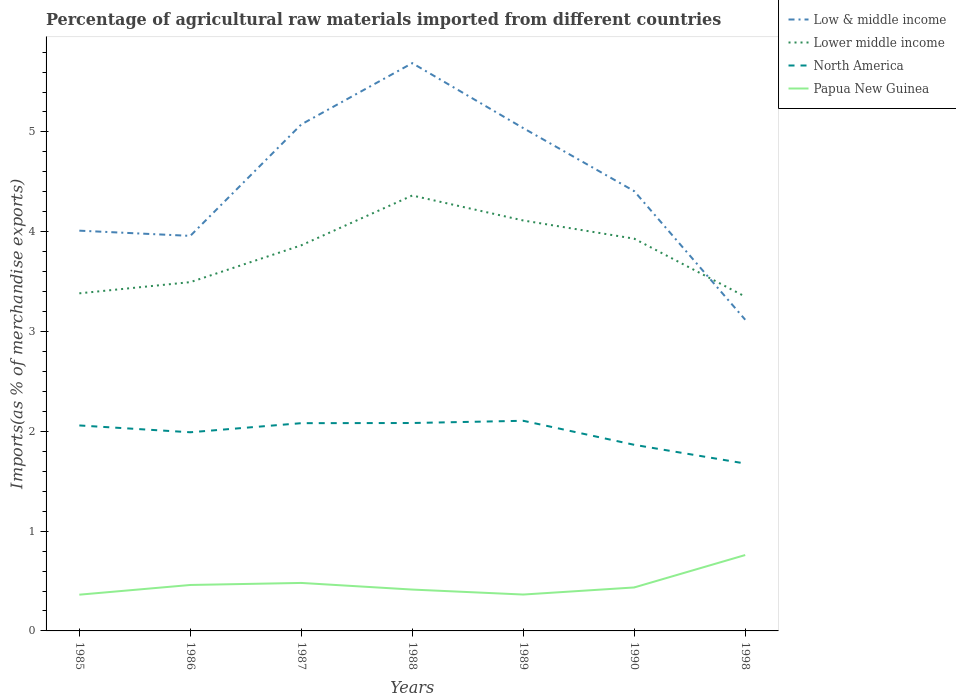Does the line corresponding to Low & middle income intersect with the line corresponding to North America?
Provide a succinct answer. No. Across all years, what is the maximum percentage of imports to different countries in Low & middle income?
Ensure brevity in your answer.  3.12. In which year was the percentage of imports to different countries in Lower middle income maximum?
Make the answer very short. 1998. What is the total percentage of imports to different countries in Low & middle income in the graph?
Keep it short and to the point. 1.28. What is the difference between the highest and the second highest percentage of imports to different countries in North America?
Make the answer very short. 0.43. What is the difference between the highest and the lowest percentage of imports to different countries in Low & middle income?
Your response must be concise. 3. Is the percentage of imports to different countries in Lower middle income strictly greater than the percentage of imports to different countries in Papua New Guinea over the years?
Keep it short and to the point. No. How many years are there in the graph?
Your answer should be compact. 7. Are the values on the major ticks of Y-axis written in scientific E-notation?
Offer a very short reply. No. Where does the legend appear in the graph?
Ensure brevity in your answer.  Top right. How many legend labels are there?
Your response must be concise. 4. What is the title of the graph?
Give a very brief answer. Percentage of agricultural raw materials imported from different countries. Does "Uzbekistan" appear as one of the legend labels in the graph?
Provide a short and direct response. No. What is the label or title of the X-axis?
Offer a very short reply. Years. What is the label or title of the Y-axis?
Provide a succinct answer. Imports(as % of merchandise exports). What is the Imports(as % of merchandise exports) in Low & middle income in 1985?
Offer a very short reply. 4.01. What is the Imports(as % of merchandise exports) of Lower middle income in 1985?
Keep it short and to the point. 3.38. What is the Imports(as % of merchandise exports) in North America in 1985?
Keep it short and to the point. 2.06. What is the Imports(as % of merchandise exports) in Papua New Guinea in 1985?
Your answer should be compact. 0.36. What is the Imports(as % of merchandise exports) in Low & middle income in 1986?
Give a very brief answer. 3.96. What is the Imports(as % of merchandise exports) of Lower middle income in 1986?
Provide a succinct answer. 3.5. What is the Imports(as % of merchandise exports) of North America in 1986?
Your answer should be compact. 1.99. What is the Imports(as % of merchandise exports) of Papua New Guinea in 1986?
Make the answer very short. 0.46. What is the Imports(as % of merchandise exports) in Low & middle income in 1987?
Make the answer very short. 5.08. What is the Imports(as % of merchandise exports) in Lower middle income in 1987?
Provide a short and direct response. 3.86. What is the Imports(as % of merchandise exports) of North America in 1987?
Make the answer very short. 2.08. What is the Imports(as % of merchandise exports) of Papua New Guinea in 1987?
Offer a very short reply. 0.48. What is the Imports(as % of merchandise exports) of Low & middle income in 1988?
Offer a very short reply. 5.69. What is the Imports(as % of merchandise exports) in Lower middle income in 1988?
Make the answer very short. 4.36. What is the Imports(as % of merchandise exports) in North America in 1988?
Offer a very short reply. 2.08. What is the Imports(as % of merchandise exports) in Papua New Guinea in 1988?
Provide a succinct answer. 0.41. What is the Imports(as % of merchandise exports) in Low & middle income in 1989?
Provide a short and direct response. 5.04. What is the Imports(as % of merchandise exports) in Lower middle income in 1989?
Keep it short and to the point. 4.11. What is the Imports(as % of merchandise exports) of North America in 1989?
Your answer should be very brief. 2.11. What is the Imports(as % of merchandise exports) in Papua New Guinea in 1989?
Provide a succinct answer. 0.36. What is the Imports(as % of merchandise exports) in Low & middle income in 1990?
Offer a very short reply. 4.41. What is the Imports(as % of merchandise exports) in Lower middle income in 1990?
Your answer should be very brief. 3.93. What is the Imports(as % of merchandise exports) of North America in 1990?
Keep it short and to the point. 1.86. What is the Imports(as % of merchandise exports) of Papua New Guinea in 1990?
Give a very brief answer. 0.44. What is the Imports(as % of merchandise exports) of Low & middle income in 1998?
Your answer should be very brief. 3.12. What is the Imports(as % of merchandise exports) in Lower middle income in 1998?
Make the answer very short. 3.35. What is the Imports(as % of merchandise exports) in North America in 1998?
Keep it short and to the point. 1.68. What is the Imports(as % of merchandise exports) of Papua New Guinea in 1998?
Provide a short and direct response. 0.76. Across all years, what is the maximum Imports(as % of merchandise exports) in Low & middle income?
Give a very brief answer. 5.69. Across all years, what is the maximum Imports(as % of merchandise exports) of Lower middle income?
Offer a very short reply. 4.36. Across all years, what is the maximum Imports(as % of merchandise exports) in North America?
Offer a very short reply. 2.11. Across all years, what is the maximum Imports(as % of merchandise exports) of Papua New Guinea?
Your response must be concise. 0.76. Across all years, what is the minimum Imports(as % of merchandise exports) of Low & middle income?
Ensure brevity in your answer.  3.12. Across all years, what is the minimum Imports(as % of merchandise exports) in Lower middle income?
Provide a succinct answer. 3.35. Across all years, what is the minimum Imports(as % of merchandise exports) in North America?
Make the answer very short. 1.68. Across all years, what is the minimum Imports(as % of merchandise exports) in Papua New Guinea?
Offer a very short reply. 0.36. What is the total Imports(as % of merchandise exports) of Low & middle income in the graph?
Ensure brevity in your answer.  31.3. What is the total Imports(as % of merchandise exports) of Lower middle income in the graph?
Make the answer very short. 26.5. What is the total Imports(as % of merchandise exports) in North America in the graph?
Your response must be concise. 13.86. What is the total Imports(as % of merchandise exports) of Papua New Guinea in the graph?
Your answer should be very brief. 3.28. What is the difference between the Imports(as % of merchandise exports) of Low & middle income in 1985 and that in 1986?
Your answer should be very brief. 0.05. What is the difference between the Imports(as % of merchandise exports) of Lower middle income in 1985 and that in 1986?
Give a very brief answer. -0.11. What is the difference between the Imports(as % of merchandise exports) of North America in 1985 and that in 1986?
Keep it short and to the point. 0.07. What is the difference between the Imports(as % of merchandise exports) in Papua New Guinea in 1985 and that in 1986?
Offer a very short reply. -0.1. What is the difference between the Imports(as % of merchandise exports) in Low & middle income in 1985 and that in 1987?
Offer a terse response. -1.06. What is the difference between the Imports(as % of merchandise exports) in Lower middle income in 1985 and that in 1987?
Keep it short and to the point. -0.48. What is the difference between the Imports(as % of merchandise exports) in North America in 1985 and that in 1987?
Your answer should be very brief. -0.02. What is the difference between the Imports(as % of merchandise exports) of Papua New Guinea in 1985 and that in 1987?
Provide a short and direct response. -0.12. What is the difference between the Imports(as % of merchandise exports) in Low & middle income in 1985 and that in 1988?
Provide a short and direct response. -1.68. What is the difference between the Imports(as % of merchandise exports) of Lower middle income in 1985 and that in 1988?
Provide a short and direct response. -0.98. What is the difference between the Imports(as % of merchandise exports) in North America in 1985 and that in 1988?
Provide a short and direct response. -0.02. What is the difference between the Imports(as % of merchandise exports) in Papua New Guinea in 1985 and that in 1988?
Your answer should be compact. -0.05. What is the difference between the Imports(as % of merchandise exports) of Low & middle income in 1985 and that in 1989?
Give a very brief answer. -1.03. What is the difference between the Imports(as % of merchandise exports) of Lower middle income in 1985 and that in 1989?
Offer a terse response. -0.73. What is the difference between the Imports(as % of merchandise exports) of North America in 1985 and that in 1989?
Your answer should be very brief. -0.05. What is the difference between the Imports(as % of merchandise exports) of Papua New Guinea in 1985 and that in 1989?
Your answer should be compact. -0. What is the difference between the Imports(as % of merchandise exports) of Low & middle income in 1985 and that in 1990?
Your response must be concise. -0.4. What is the difference between the Imports(as % of merchandise exports) of Lower middle income in 1985 and that in 1990?
Give a very brief answer. -0.55. What is the difference between the Imports(as % of merchandise exports) of North America in 1985 and that in 1990?
Offer a very short reply. 0.19. What is the difference between the Imports(as % of merchandise exports) of Papua New Guinea in 1985 and that in 1990?
Your answer should be compact. -0.07. What is the difference between the Imports(as % of merchandise exports) of Low & middle income in 1985 and that in 1998?
Ensure brevity in your answer.  0.89. What is the difference between the Imports(as % of merchandise exports) of Lower middle income in 1985 and that in 1998?
Make the answer very short. 0.03. What is the difference between the Imports(as % of merchandise exports) in North America in 1985 and that in 1998?
Ensure brevity in your answer.  0.38. What is the difference between the Imports(as % of merchandise exports) of Papua New Guinea in 1985 and that in 1998?
Make the answer very short. -0.4. What is the difference between the Imports(as % of merchandise exports) in Low & middle income in 1986 and that in 1987?
Offer a terse response. -1.12. What is the difference between the Imports(as % of merchandise exports) of Lower middle income in 1986 and that in 1987?
Make the answer very short. -0.37. What is the difference between the Imports(as % of merchandise exports) of North America in 1986 and that in 1987?
Give a very brief answer. -0.09. What is the difference between the Imports(as % of merchandise exports) in Papua New Guinea in 1986 and that in 1987?
Offer a terse response. -0.02. What is the difference between the Imports(as % of merchandise exports) of Low & middle income in 1986 and that in 1988?
Make the answer very short. -1.73. What is the difference between the Imports(as % of merchandise exports) of Lower middle income in 1986 and that in 1988?
Your response must be concise. -0.87. What is the difference between the Imports(as % of merchandise exports) in North America in 1986 and that in 1988?
Give a very brief answer. -0.09. What is the difference between the Imports(as % of merchandise exports) of Papua New Guinea in 1986 and that in 1988?
Provide a short and direct response. 0.05. What is the difference between the Imports(as % of merchandise exports) in Low & middle income in 1986 and that in 1989?
Provide a succinct answer. -1.08. What is the difference between the Imports(as % of merchandise exports) of Lower middle income in 1986 and that in 1989?
Ensure brevity in your answer.  -0.62. What is the difference between the Imports(as % of merchandise exports) of North America in 1986 and that in 1989?
Make the answer very short. -0.12. What is the difference between the Imports(as % of merchandise exports) in Papua New Guinea in 1986 and that in 1989?
Keep it short and to the point. 0.1. What is the difference between the Imports(as % of merchandise exports) in Low & middle income in 1986 and that in 1990?
Your response must be concise. -0.45. What is the difference between the Imports(as % of merchandise exports) of Lower middle income in 1986 and that in 1990?
Make the answer very short. -0.44. What is the difference between the Imports(as % of merchandise exports) in North America in 1986 and that in 1990?
Make the answer very short. 0.13. What is the difference between the Imports(as % of merchandise exports) in Papua New Guinea in 1986 and that in 1990?
Give a very brief answer. 0.02. What is the difference between the Imports(as % of merchandise exports) in Low & middle income in 1986 and that in 1998?
Give a very brief answer. 0.84. What is the difference between the Imports(as % of merchandise exports) in Lower middle income in 1986 and that in 1998?
Provide a short and direct response. 0.15. What is the difference between the Imports(as % of merchandise exports) in North America in 1986 and that in 1998?
Your answer should be compact. 0.31. What is the difference between the Imports(as % of merchandise exports) in Papua New Guinea in 1986 and that in 1998?
Give a very brief answer. -0.3. What is the difference between the Imports(as % of merchandise exports) of Low & middle income in 1987 and that in 1988?
Your answer should be very brief. -0.61. What is the difference between the Imports(as % of merchandise exports) of Lower middle income in 1987 and that in 1988?
Your answer should be compact. -0.5. What is the difference between the Imports(as % of merchandise exports) of North America in 1987 and that in 1988?
Offer a terse response. -0. What is the difference between the Imports(as % of merchandise exports) in Papua New Guinea in 1987 and that in 1988?
Ensure brevity in your answer.  0.07. What is the difference between the Imports(as % of merchandise exports) of Low & middle income in 1987 and that in 1989?
Your response must be concise. 0.04. What is the difference between the Imports(as % of merchandise exports) in Lower middle income in 1987 and that in 1989?
Your response must be concise. -0.25. What is the difference between the Imports(as % of merchandise exports) in North America in 1987 and that in 1989?
Your answer should be compact. -0.02. What is the difference between the Imports(as % of merchandise exports) of Papua New Guinea in 1987 and that in 1989?
Your response must be concise. 0.12. What is the difference between the Imports(as % of merchandise exports) in Low & middle income in 1987 and that in 1990?
Ensure brevity in your answer.  0.67. What is the difference between the Imports(as % of merchandise exports) in Lower middle income in 1987 and that in 1990?
Ensure brevity in your answer.  -0.07. What is the difference between the Imports(as % of merchandise exports) in North America in 1987 and that in 1990?
Make the answer very short. 0.22. What is the difference between the Imports(as % of merchandise exports) in Papua New Guinea in 1987 and that in 1990?
Provide a short and direct response. 0.05. What is the difference between the Imports(as % of merchandise exports) in Low & middle income in 1987 and that in 1998?
Offer a very short reply. 1.96. What is the difference between the Imports(as % of merchandise exports) in Lower middle income in 1987 and that in 1998?
Offer a terse response. 0.51. What is the difference between the Imports(as % of merchandise exports) in North America in 1987 and that in 1998?
Offer a terse response. 0.4. What is the difference between the Imports(as % of merchandise exports) in Papua New Guinea in 1987 and that in 1998?
Your answer should be compact. -0.28. What is the difference between the Imports(as % of merchandise exports) of Low & middle income in 1988 and that in 1989?
Your response must be concise. 0.65. What is the difference between the Imports(as % of merchandise exports) of Lower middle income in 1988 and that in 1989?
Offer a very short reply. 0.25. What is the difference between the Imports(as % of merchandise exports) of North America in 1988 and that in 1989?
Offer a terse response. -0.02. What is the difference between the Imports(as % of merchandise exports) of Papua New Guinea in 1988 and that in 1989?
Provide a short and direct response. 0.05. What is the difference between the Imports(as % of merchandise exports) in Low & middle income in 1988 and that in 1990?
Your response must be concise. 1.28. What is the difference between the Imports(as % of merchandise exports) of Lower middle income in 1988 and that in 1990?
Ensure brevity in your answer.  0.43. What is the difference between the Imports(as % of merchandise exports) of North America in 1988 and that in 1990?
Provide a short and direct response. 0.22. What is the difference between the Imports(as % of merchandise exports) in Papua New Guinea in 1988 and that in 1990?
Your answer should be very brief. -0.02. What is the difference between the Imports(as % of merchandise exports) in Low & middle income in 1988 and that in 1998?
Your answer should be very brief. 2.57. What is the difference between the Imports(as % of merchandise exports) of Lower middle income in 1988 and that in 1998?
Make the answer very short. 1.01. What is the difference between the Imports(as % of merchandise exports) of North America in 1988 and that in 1998?
Provide a short and direct response. 0.41. What is the difference between the Imports(as % of merchandise exports) of Papua New Guinea in 1988 and that in 1998?
Provide a short and direct response. -0.35. What is the difference between the Imports(as % of merchandise exports) in Low & middle income in 1989 and that in 1990?
Make the answer very short. 0.63. What is the difference between the Imports(as % of merchandise exports) in Lower middle income in 1989 and that in 1990?
Offer a terse response. 0.18. What is the difference between the Imports(as % of merchandise exports) in North America in 1989 and that in 1990?
Ensure brevity in your answer.  0.24. What is the difference between the Imports(as % of merchandise exports) in Papua New Guinea in 1989 and that in 1990?
Your answer should be very brief. -0.07. What is the difference between the Imports(as % of merchandise exports) in Low & middle income in 1989 and that in 1998?
Keep it short and to the point. 1.92. What is the difference between the Imports(as % of merchandise exports) in Lower middle income in 1989 and that in 1998?
Keep it short and to the point. 0.76. What is the difference between the Imports(as % of merchandise exports) of North America in 1989 and that in 1998?
Give a very brief answer. 0.43. What is the difference between the Imports(as % of merchandise exports) of Papua New Guinea in 1989 and that in 1998?
Provide a short and direct response. -0.4. What is the difference between the Imports(as % of merchandise exports) of Low & middle income in 1990 and that in 1998?
Keep it short and to the point. 1.29. What is the difference between the Imports(as % of merchandise exports) in Lower middle income in 1990 and that in 1998?
Your response must be concise. 0.58. What is the difference between the Imports(as % of merchandise exports) in North America in 1990 and that in 1998?
Your answer should be compact. 0.19. What is the difference between the Imports(as % of merchandise exports) of Papua New Guinea in 1990 and that in 1998?
Provide a short and direct response. -0.32. What is the difference between the Imports(as % of merchandise exports) in Low & middle income in 1985 and the Imports(as % of merchandise exports) in Lower middle income in 1986?
Make the answer very short. 0.52. What is the difference between the Imports(as % of merchandise exports) in Low & middle income in 1985 and the Imports(as % of merchandise exports) in North America in 1986?
Provide a succinct answer. 2.02. What is the difference between the Imports(as % of merchandise exports) of Low & middle income in 1985 and the Imports(as % of merchandise exports) of Papua New Guinea in 1986?
Offer a terse response. 3.55. What is the difference between the Imports(as % of merchandise exports) of Lower middle income in 1985 and the Imports(as % of merchandise exports) of North America in 1986?
Keep it short and to the point. 1.39. What is the difference between the Imports(as % of merchandise exports) of Lower middle income in 1985 and the Imports(as % of merchandise exports) of Papua New Guinea in 1986?
Offer a very short reply. 2.92. What is the difference between the Imports(as % of merchandise exports) of North America in 1985 and the Imports(as % of merchandise exports) of Papua New Guinea in 1986?
Your answer should be compact. 1.6. What is the difference between the Imports(as % of merchandise exports) of Low & middle income in 1985 and the Imports(as % of merchandise exports) of Lower middle income in 1987?
Give a very brief answer. 0.15. What is the difference between the Imports(as % of merchandise exports) of Low & middle income in 1985 and the Imports(as % of merchandise exports) of North America in 1987?
Provide a succinct answer. 1.93. What is the difference between the Imports(as % of merchandise exports) of Low & middle income in 1985 and the Imports(as % of merchandise exports) of Papua New Guinea in 1987?
Your response must be concise. 3.53. What is the difference between the Imports(as % of merchandise exports) in Lower middle income in 1985 and the Imports(as % of merchandise exports) in North America in 1987?
Your response must be concise. 1.3. What is the difference between the Imports(as % of merchandise exports) in Lower middle income in 1985 and the Imports(as % of merchandise exports) in Papua New Guinea in 1987?
Offer a terse response. 2.9. What is the difference between the Imports(as % of merchandise exports) of North America in 1985 and the Imports(as % of merchandise exports) of Papua New Guinea in 1987?
Give a very brief answer. 1.58. What is the difference between the Imports(as % of merchandise exports) of Low & middle income in 1985 and the Imports(as % of merchandise exports) of Lower middle income in 1988?
Give a very brief answer. -0.35. What is the difference between the Imports(as % of merchandise exports) in Low & middle income in 1985 and the Imports(as % of merchandise exports) in North America in 1988?
Your response must be concise. 1.93. What is the difference between the Imports(as % of merchandise exports) of Low & middle income in 1985 and the Imports(as % of merchandise exports) of Papua New Guinea in 1988?
Offer a terse response. 3.6. What is the difference between the Imports(as % of merchandise exports) in Lower middle income in 1985 and the Imports(as % of merchandise exports) in North America in 1988?
Offer a very short reply. 1.3. What is the difference between the Imports(as % of merchandise exports) of Lower middle income in 1985 and the Imports(as % of merchandise exports) of Papua New Guinea in 1988?
Your answer should be very brief. 2.97. What is the difference between the Imports(as % of merchandise exports) in North America in 1985 and the Imports(as % of merchandise exports) in Papua New Guinea in 1988?
Offer a very short reply. 1.64. What is the difference between the Imports(as % of merchandise exports) in Low & middle income in 1985 and the Imports(as % of merchandise exports) in Lower middle income in 1989?
Your answer should be very brief. -0.1. What is the difference between the Imports(as % of merchandise exports) in Low & middle income in 1985 and the Imports(as % of merchandise exports) in North America in 1989?
Provide a short and direct response. 1.91. What is the difference between the Imports(as % of merchandise exports) of Low & middle income in 1985 and the Imports(as % of merchandise exports) of Papua New Guinea in 1989?
Provide a short and direct response. 3.65. What is the difference between the Imports(as % of merchandise exports) in Lower middle income in 1985 and the Imports(as % of merchandise exports) in North America in 1989?
Ensure brevity in your answer.  1.28. What is the difference between the Imports(as % of merchandise exports) in Lower middle income in 1985 and the Imports(as % of merchandise exports) in Papua New Guinea in 1989?
Provide a short and direct response. 3.02. What is the difference between the Imports(as % of merchandise exports) in North America in 1985 and the Imports(as % of merchandise exports) in Papua New Guinea in 1989?
Make the answer very short. 1.69. What is the difference between the Imports(as % of merchandise exports) in Low & middle income in 1985 and the Imports(as % of merchandise exports) in Lower middle income in 1990?
Provide a short and direct response. 0.08. What is the difference between the Imports(as % of merchandise exports) in Low & middle income in 1985 and the Imports(as % of merchandise exports) in North America in 1990?
Ensure brevity in your answer.  2.15. What is the difference between the Imports(as % of merchandise exports) in Low & middle income in 1985 and the Imports(as % of merchandise exports) in Papua New Guinea in 1990?
Your response must be concise. 3.58. What is the difference between the Imports(as % of merchandise exports) in Lower middle income in 1985 and the Imports(as % of merchandise exports) in North America in 1990?
Offer a terse response. 1.52. What is the difference between the Imports(as % of merchandise exports) of Lower middle income in 1985 and the Imports(as % of merchandise exports) of Papua New Guinea in 1990?
Make the answer very short. 2.95. What is the difference between the Imports(as % of merchandise exports) in North America in 1985 and the Imports(as % of merchandise exports) in Papua New Guinea in 1990?
Your answer should be compact. 1.62. What is the difference between the Imports(as % of merchandise exports) in Low & middle income in 1985 and the Imports(as % of merchandise exports) in Lower middle income in 1998?
Give a very brief answer. 0.66. What is the difference between the Imports(as % of merchandise exports) in Low & middle income in 1985 and the Imports(as % of merchandise exports) in North America in 1998?
Your answer should be compact. 2.33. What is the difference between the Imports(as % of merchandise exports) in Low & middle income in 1985 and the Imports(as % of merchandise exports) in Papua New Guinea in 1998?
Provide a succinct answer. 3.25. What is the difference between the Imports(as % of merchandise exports) of Lower middle income in 1985 and the Imports(as % of merchandise exports) of North America in 1998?
Your answer should be very brief. 1.71. What is the difference between the Imports(as % of merchandise exports) of Lower middle income in 1985 and the Imports(as % of merchandise exports) of Papua New Guinea in 1998?
Offer a very short reply. 2.62. What is the difference between the Imports(as % of merchandise exports) of North America in 1985 and the Imports(as % of merchandise exports) of Papua New Guinea in 1998?
Provide a succinct answer. 1.3. What is the difference between the Imports(as % of merchandise exports) in Low & middle income in 1986 and the Imports(as % of merchandise exports) in Lower middle income in 1987?
Ensure brevity in your answer.  0.09. What is the difference between the Imports(as % of merchandise exports) in Low & middle income in 1986 and the Imports(as % of merchandise exports) in North America in 1987?
Make the answer very short. 1.88. What is the difference between the Imports(as % of merchandise exports) of Low & middle income in 1986 and the Imports(as % of merchandise exports) of Papua New Guinea in 1987?
Ensure brevity in your answer.  3.48. What is the difference between the Imports(as % of merchandise exports) of Lower middle income in 1986 and the Imports(as % of merchandise exports) of North America in 1987?
Keep it short and to the point. 1.41. What is the difference between the Imports(as % of merchandise exports) of Lower middle income in 1986 and the Imports(as % of merchandise exports) of Papua New Guinea in 1987?
Provide a succinct answer. 3.01. What is the difference between the Imports(as % of merchandise exports) of North America in 1986 and the Imports(as % of merchandise exports) of Papua New Guinea in 1987?
Keep it short and to the point. 1.51. What is the difference between the Imports(as % of merchandise exports) in Low & middle income in 1986 and the Imports(as % of merchandise exports) in Lower middle income in 1988?
Offer a very short reply. -0.4. What is the difference between the Imports(as % of merchandise exports) of Low & middle income in 1986 and the Imports(as % of merchandise exports) of North America in 1988?
Give a very brief answer. 1.88. What is the difference between the Imports(as % of merchandise exports) of Low & middle income in 1986 and the Imports(as % of merchandise exports) of Papua New Guinea in 1988?
Your answer should be compact. 3.54. What is the difference between the Imports(as % of merchandise exports) of Lower middle income in 1986 and the Imports(as % of merchandise exports) of North America in 1988?
Offer a terse response. 1.41. What is the difference between the Imports(as % of merchandise exports) of Lower middle income in 1986 and the Imports(as % of merchandise exports) of Papua New Guinea in 1988?
Offer a terse response. 3.08. What is the difference between the Imports(as % of merchandise exports) of North America in 1986 and the Imports(as % of merchandise exports) of Papua New Guinea in 1988?
Keep it short and to the point. 1.58. What is the difference between the Imports(as % of merchandise exports) of Low & middle income in 1986 and the Imports(as % of merchandise exports) of Lower middle income in 1989?
Offer a very short reply. -0.15. What is the difference between the Imports(as % of merchandise exports) in Low & middle income in 1986 and the Imports(as % of merchandise exports) in North America in 1989?
Ensure brevity in your answer.  1.85. What is the difference between the Imports(as % of merchandise exports) in Low & middle income in 1986 and the Imports(as % of merchandise exports) in Papua New Guinea in 1989?
Provide a short and direct response. 3.59. What is the difference between the Imports(as % of merchandise exports) in Lower middle income in 1986 and the Imports(as % of merchandise exports) in North America in 1989?
Your answer should be compact. 1.39. What is the difference between the Imports(as % of merchandise exports) of Lower middle income in 1986 and the Imports(as % of merchandise exports) of Papua New Guinea in 1989?
Your answer should be very brief. 3.13. What is the difference between the Imports(as % of merchandise exports) in North America in 1986 and the Imports(as % of merchandise exports) in Papua New Guinea in 1989?
Ensure brevity in your answer.  1.63. What is the difference between the Imports(as % of merchandise exports) in Low & middle income in 1986 and the Imports(as % of merchandise exports) in Lower middle income in 1990?
Your answer should be very brief. 0.03. What is the difference between the Imports(as % of merchandise exports) in Low & middle income in 1986 and the Imports(as % of merchandise exports) in North America in 1990?
Keep it short and to the point. 2.09. What is the difference between the Imports(as % of merchandise exports) of Low & middle income in 1986 and the Imports(as % of merchandise exports) of Papua New Guinea in 1990?
Offer a terse response. 3.52. What is the difference between the Imports(as % of merchandise exports) in Lower middle income in 1986 and the Imports(as % of merchandise exports) in North America in 1990?
Provide a succinct answer. 1.63. What is the difference between the Imports(as % of merchandise exports) of Lower middle income in 1986 and the Imports(as % of merchandise exports) of Papua New Guinea in 1990?
Ensure brevity in your answer.  3.06. What is the difference between the Imports(as % of merchandise exports) of North America in 1986 and the Imports(as % of merchandise exports) of Papua New Guinea in 1990?
Ensure brevity in your answer.  1.55. What is the difference between the Imports(as % of merchandise exports) of Low & middle income in 1986 and the Imports(as % of merchandise exports) of Lower middle income in 1998?
Ensure brevity in your answer.  0.61. What is the difference between the Imports(as % of merchandise exports) of Low & middle income in 1986 and the Imports(as % of merchandise exports) of North America in 1998?
Offer a very short reply. 2.28. What is the difference between the Imports(as % of merchandise exports) in Low & middle income in 1986 and the Imports(as % of merchandise exports) in Papua New Guinea in 1998?
Offer a terse response. 3.2. What is the difference between the Imports(as % of merchandise exports) in Lower middle income in 1986 and the Imports(as % of merchandise exports) in North America in 1998?
Make the answer very short. 1.82. What is the difference between the Imports(as % of merchandise exports) of Lower middle income in 1986 and the Imports(as % of merchandise exports) of Papua New Guinea in 1998?
Provide a succinct answer. 2.73. What is the difference between the Imports(as % of merchandise exports) of North America in 1986 and the Imports(as % of merchandise exports) of Papua New Guinea in 1998?
Your response must be concise. 1.23. What is the difference between the Imports(as % of merchandise exports) of Low & middle income in 1987 and the Imports(as % of merchandise exports) of Lower middle income in 1988?
Provide a succinct answer. 0.71. What is the difference between the Imports(as % of merchandise exports) of Low & middle income in 1987 and the Imports(as % of merchandise exports) of North America in 1988?
Keep it short and to the point. 2.99. What is the difference between the Imports(as % of merchandise exports) in Low & middle income in 1987 and the Imports(as % of merchandise exports) in Papua New Guinea in 1988?
Offer a very short reply. 4.66. What is the difference between the Imports(as % of merchandise exports) of Lower middle income in 1987 and the Imports(as % of merchandise exports) of North America in 1988?
Provide a short and direct response. 1.78. What is the difference between the Imports(as % of merchandise exports) of Lower middle income in 1987 and the Imports(as % of merchandise exports) of Papua New Guinea in 1988?
Provide a short and direct response. 3.45. What is the difference between the Imports(as % of merchandise exports) of North America in 1987 and the Imports(as % of merchandise exports) of Papua New Guinea in 1988?
Ensure brevity in your answer.  1.67. What is the difference between the Imports(as % of merchandise exports) of Low & middle income in 1987 and the Imports(as % of merchandise exports) of Lower middle income in 1989?
Your answer should be very brief. 0.96. What is the difference between the Imports(as % of merchandise exports) in Low & middle income in 1987 and the Imports(as % of merchandise exports) in North America in 1989?
Offer a very short reply. 2.97. What is the difference between the Imports(as % of merchandise exports) in Low & middle income in 1987 and the Imports(as % of merchandise exports) in Papua New Guinea in 1989?
Make the answer very short. 4.71. What is the difference between the Imports(as % of merchandise exports) of Lower middle income in 1987 and the Imports(as % of merchandise exports) of North America in 1989?
Your answer should be compact. 1.76. What is the difference between the Imports(as % of merchandise exports) of Lower middle income in 1987 and the Imports(as % of merchandise exports) of Papua New Guinea in 1989?
Provide a short and direct response. 3.5. What is the difference between the Imports(as % of merchandise exports) in North America in 1987 and the Imports(as % of merchandise exports) in Papua New Guinea in 1989?
Your answer should be very brief. 1.72. What is the difference between the Imports(as % of merchandise exports) in Low & middle income in 1987 and the Imports(as % of merchandise exports) in Lower middle income in 1990?
Your response must be concise. 1.15. What is the difference between the Imports(as % of merchandise exports) of Low & middle income in 1987 and the Imports(as % of merchandise exports) of North America in 1990?
Offer a very short reply. 3.21. What is the difference between the Imports(as % of merchandise exports) of Low & middle income in 1987 and the Imports(as % of merchandise exports) of Papua New Guinea in 1990?
Your answer should be compact. 4.64. What is the difference between the Imports(as % of merchandise exports) in Lower middle income in 1987 and the Imports(as % of merchandise exports) in North America in 1990?
Your response must be concise. 2. What is the difference between the Imports(as % of merchandise exports) of Lower middle income in 1987 and the Imports(as % of merchandise exports) of Papua New Guinea in 1990?
Give a very brief answer. 3.43. What is the difference between the Imports(as % of merchandise exports) of North America in 1987 and the Imports(as % of merchandise exports) of Papua New Guinea in 1990?
Give a very brief answer. 1.65. What is the difference between the Imports(as % of merchandise exports) in Low & middle income in 1987 and the Imports(as % of merchandise exports) in Lower middle income in 1998?
Your answer should be compact. 1.73. What is the difference between the Imports(as % of merchandise exports) in Low & middle income in 1987 and the Imports(as % of merchandise exports) in North America in 1998?
Offer a very short reply. 3.4. What is the difference between the Imports(as % of merchandise exports) in Low & middle income in 1987 and the Imports(as % of merchandise exports) in Papua New Guinea in 1998?
Offer a terse response. 4.31. What is the difference between the Imports(as % of merchandise exports) in Lower middle income in 1987 and the Imports(as % of merchandise exports) in North America in 1998?
Give a very brief answer. 2.19. What is the difference between the Imports(as % of merchandise exports) of Lower middle income in 1987 and the Imports(as % of merchandise exports) of Papua New Guinea in 1998?
Keep it short and to the point. 3.1. What is the difference between the Imports(as % of merchandise exports) in North America in 1987 and the Imports(as % of merchandise exports) in Papua New Guinea in 1998?
Ensure brevity in your answer.  1.32. What is the difference between the Imports(as % of merchandise exports) in Low & middle income in 1988 and the Imports(as % of merchandise exports) in Lower middle income in 1989?
Keep it short and to the point. 1.58. What is the difference between the Imports(as % of merchandise exports) in Low & middle income in 1988 and the Imports(as % of merchandise exports) in North America in 1989?
Provide a short and direct response. 3.58. What is the difference between the Imports(as % of merchandise exports) of Low & middle income in 1988 and the Imports(as % of merchandise exports) of Papua New Guinea in 1989?
Your response must be concise. 5.32. What is the difference between the Imports(as % of merchandise exports) in Lower middle income in 1988 and the Imports(as % of merchandise exports) in North America in 1989?
Offer a terse response. 2.26. What is the difference between the Imports(as % of merchandise exports) in Lower middle income in 1988 and the Imports(as % of merchandise exports) in Papua New Guinea in 1989?
Provide a succinct answer. 4. What is the difference between the Imports(as % of merchandise exports) of North America in 1988 and the Imports(as % of merchandise exports) of Papua New Guinea in 1989?
Your answer should be very brief. 1.72. What is the difference between the Imports(as % of merchandise exports) of Low & middle income in 1988 and the Imports(as % of merchandise exports) of Lower middle income in 1990?
Provide a succinct answer. 1.76. What is the difference between the Imports(as % of merchandise exports) of Low & middle income in 1988 and the Imports(as % of merchandise exports) of North America in 1990?
Your response must be concise. 3.82. What is the difference between the Imports(as % of merchandise exports) in Low & middle income in 1988 and the Imports(as % of merchandise exports) in Papua New Guinea in 1990?
Your answer should be very brief. 5.25. What is the difference between the Imports(as % of merchandise exports) in Lower middle income in 1988 and the Imports(as % of merchandise exports) in North America in 1990?
Give a very brief answer. 2.5. What is the difference between the Imports(as % of merchandise exports) of Lower middle income in 1988 and the Imports(as % of merchandise exports) of Papua New Guinea in 1990?
Offer a terse response. 3.93. What is the difference between the Imports(as % of merchandise exports) in North America in 1988 and the Imports(as % of merchandise exports) in Papua New Guinea in 1990?
Offer a terse response. 1.65. What is the difference between the Imports(as % of merchandise exports) in Low & middle income in 1988 and the Imports(as % of merchandise exports) in Lower middle income in 1998?
Give a very brief answer. 2.34. What is the difference between the Imports(as % of merchandise exports) of Low & middle income in 1988 and the Imports(as % of merchandise exports) of North America in 1998?
Your answer should be compact. 4.01. What is the difference between the Imports(as % of merchandise exports) in Low & middle income in 1988 and the Imports(as % of merchandise exports) in Papua New Guinea in 1998?
Offer a terse response. 4.93. What is the difference between the Imports(as % of merchandise exports) in Lower middle income in 1988 and the Imports(as % of merchandise exports) in North America in 1998?
Ensure brevity in your answer.  2.69. What is the difference between the Imports(as % of merchandise exports) of Lower middle income in 1988 and the Imports(as % of merchandise exports) of Papua New Guinea in 1998?
Offer a terse response. 3.6. What is the difference between the Imports(as % of merchandise exports) in North America in 1988 and the Imports(as % of merchandise exports) in Papua New Guinea in 1998?
Your answer should be compact. 1.32. What is the difference between the Imports(as % of merchandise exports) in Low & middle income in 1989 and the Imports(as % of merchandise exports) in Lower middle income in 1990?
Ensure brevity in your answer.  1.11. What is the difference between the Imports(as % of merchandise exports) of Low & middle income in 1989 and the Imports(as % of merchandise exports) of North America in 1990?
Your response must be concise. 3.17. What is the difference between the Imports(as % of merchandise exports) of Low & middle income in 1989 and the Imports(as % of merchandise exports) of Papua New Guinea in 1990?
Keep it short and to the point. 4.6. What is the difference between the Imports(as % of merchandise exports) in Lower middle income in 1989 and the Imports(as % of merchandise exports) in North America in 1990?
Provide a short and direct response. 2.25. What is the difference between the Imports(as % of merchandise exports) of Lower middle income in 1989 and the Imports(as % of merchandise exports) of Papua New Guinea in 1990?
Ensure brevity in your answer.  3.68. What is the difference between the Imports(as % of merchandise exports) in North America in 1989 and the Imports(as % of merchandise exports) in Papua New Guinea in 1990?
Provide a succinct answer. 1.67. What is the difference between the Imports(as % of merchandise exports) in Low & middle income in 1989 and the Imports(as % of merchandise exports) in Lower middle income in 1998?
Offer a very short reply. 1.69. What is the difference between the Imports(as % of merchandise exports) of Low & middle income in 1989 and the Imports(as % of merchandise exports) of North America in 1998?
Your response must be concise. 3.36. What is the difference between the Imports(as % of merchandise exports) of Low & middle income in 1989 and the Imports(as % of merchandise exports) of Papua New Guinea in 1998?
Your response must be concise. 4.28. What is the difference between the Imports(as % of merchandise exports) of Lower middle income in 1989 and the Imports(as % of merchandise exports) of North America in 1998?
Offer a very short reply. 2.44. What is the difference between the Imports(as % of merchandise exports) in Lower middle income in 1989 and the Imports(as % of merchandise exports) in Papua New Guinea in 1998?
Ensure brevity in your answer.  3.35. What is the difference between the Imports(as % of merchandise exports) of North America in 1989 and the Imports(as % of merchandise exports) of Papua New Guinea in 1998?
Make the answer very short. 1.35. What is the difference between the Imports(as % of merchandise exports) of Low & middle income in 1990 and the Imports(as % of merchandise exports) of Lower middle income in 1998?
Make the answer very short. 1.06. What is the difference between the Imports(as % of merchandise exports) of Low & middle income in 1990 and the Imports(as % of merchandise exports) of North America in 1998?
Offer a very short reply. 2.73. What is the difference between the Imports(as % of merchandise exports) in Low & middle income in 1990 and the Imports(as % of merchandise exports) in Papua New Guinea in 1998?
Your response must be concise. 3.65. What is the difference between the Imports(as % of merchandise exports) of Lower middle income in 1990 and the Imports(as % of merchandise exports) of North America in 1998?
Keep it short and to the point. 2.25. What is the difference between the Imports(as % of merchandise exports) of Lower middle income in 1990 and the Imports(as % of merchandise exports) of Papua New Guinea in 1998?
Offer a terse response. 3.17. What is the difference between the Imports(as % of merchandise exports) of North America in 1990 and the Imports(as % of merchandise exports) of Papua New Guinea in 1998?
Your response must be concise. 1.1. What is the average Imports(as % of merchandise exports) of Low & middle income per year?
Your response must be concise. 4.47. What is the average Imports(as % of merchandise exports) of Lower middle income per year?
Your answer should be very brief. 3.79. What is the average Imports(as % of merchandise exports) of North America per year?
Your response must be concise. 1.98. What is the average Imports(as % of merchandise exports) in Papua New Guinea per year?
Ensure brevity in your answer.  0.47. In the year 1985, what is the difference between the Imports(as % of merchandise exports) in Low & middle income and Imports(as % of merchandise exports) in Lower middle income?
Make the answer very short. 0.63. In the year 1985, what is the difference between the Imports(as % of merchandise exports) of Low & middle income and Imports(as % of merchandise exports) of North America?
Offer a terse response. 1.95. In the year 1985, what is the difference between the Imports(as % of merchandise exports) of Low & middle income and Imports(as % of merchandise exports) of Papua New Guinea?
Provide a short and direct response. 3.65. In the year 1985, what is the difference between the Imports(as % of merchandise exports) in Lower middle income and Imports(as % of merchandise exports) in North America?
Make the answer very short. 1.32. In the year 1985, what is the difference between the Imports(as % of merchandise exports) in Lower middle income and Imports(as % of merchandise exports) in Papua New Guinea?
Make the answer very short. 3.02. In the year 1985, what is the difference between the Imports(as % of merchandise exports) of North America and Imports(as % of merchandise exports) of Papua New Guinea?
Provide a short and direct response. 1.7. In the year 1986, what is the difference between the Imports(as % of merchandise exports) in Low & middle income and Imports(as % of merchandise exports) in Lower middle income?
Provide a short and direct response. 0.46. In the year 1986, what is the difference between the Imports(as % of merchandise exports) of Low & middle income and Imports(as % of merchandise exports) of North America?
Provide a short and direct response. 1.97. In the year 1986, what is the difference between the Imports(as % of merchandise exports) in Low & middle income and Imports(as % of merchandise exports) in Papua New Guinea?
Your answer should be very brief. 3.5. In the year 1986, what is the difference between the Imports(as % of merchandise exports) in Lower middle income and Imports(as % of merchandise exports) in North America?
Provide a succinct answer. 1.5. In the year 1986, what is the difference between the Imports(as % of merchandise exports) of Lower middle income and Imports(as % of merchandise exports) of Papua New Guinea?
Keep it short and to the point. 3.03. In the year 1986, what is the difference between the Imports(as % of merchandise exports) in North America and Imports(as % of merchandise exports) in Papua New Guinea?
Your response must be concise. 1.53. In the year 1987, what is the difference between the Imports(as % of merchandise exports) of Low & middle income and Imports(as % of merchandise exports) of Lower middle income?
Provide a succinct answer. 1.21. In the year 1987, what is the difference between the Imports(as % of merchandise exports) of Low & middle income and Imports(as % of merchandise exports) of North America?
Provide a succinct answer. 2.99. In the year 1987, what is the difference between the Imports(as % of merchandise exports) of Low & middle income and Imports(as % of merchandise exports) of Papua New Guinea?
Your response must be concise. 4.59. In the year 1987, what is the difference between the Imports(as % of merchandise exports) of Lower middle income and Imports(as % of merchandise exports) of North America?
Ensure brevity in your answer.  1.78. In the year 1987, what is the difference between the Imports(as % of merchandise exports) in Lower middle income and Imports(as % of merchandise exports) in Papua New Guinea?
Provide a short and direct response. 3.38. In the year 1987, what is the difference between the Imports(as % of merchandise exports) of North America and Imports(as % of merchandise exports) of Papua New Guinea?
Make the answer very short. 1.6. In the year 1988, what is the difference between the Imports(as % of merchandise exports) of Low & middle income and Imports(as % of merchandise exports) of Lower middle income?
Provide a succinct answer. 1.33. In the year 1988, what is the difference between the Imports(as % of merchandise exports) in Low & middle income and Imports(as % of merchandise exports) in North America?
Provide a short and direct response. 3.61. In the year 1988, what is the difference between the Imports(as % of merchandise exports) in Low & middle income and Imports(as % of merchandise exports) in Papua New Guinea?
Keep it short and to the point. 5.27. In the year 1988, what is the difference between the Imports(as % of merchandise exports) of Lower middle income and Imports(as % of merchandise exports) of North America?
Keep it short and to the point. 2.28. In the year 1988, what is the difference between the Imports(as % of merchandise exports) in Lower middle income and Imports(as % of merchandise exports) in Papua New Guinea?
Provide a succinct answer. 3.95. In the year 1988, what is the difference between the Imports(as % of merchandise exports) of North America and Imports(as % of merchandise exports) of Papua New Guinea?
Your response must be concise. 1.67. In the year 1989, what is the difference between the Imports(as % of merchandise exports) in Low & middle income and Imports(as % of merchandise exports) in Lower middle income?
Your answer should be very brief. 0.93. In the year 1989, what is the difference between the Imports(as % of merchandise exports) of Low & middle income and Imports(as % of merchandise exports) of North America?
Ensure brevity in your answer.  2.93. In the year 1989, what is the difference between the Imports(as % of merchandise exports) of Low & middle income and Imports(as % of merchandise exports) of Papua New Guinea?
Provide a short and direct response. 4.67. In the year 1989, what is the difference between the Imports(as % of merchandise exports) in Lower middle income and Imports(as % of merchandise exports) in North America?
Make the answer very short. 2.01. In the year 1989, what is the difference between the Imports(as % of merchandise exports) in Lower middle income and Imports(as % of merchandise exports) in Papua New Guinea?
Make the answer very short. 3.75. In the year 1989, what is the difference between the Imports(as % of merchandise exports) in North America and Imports(as % of merchandise exports) in Papua New Guinea?
Your answer should be very brief. 1.74. In the year 1990, what is the difference between the Imports(as % of merchandise exports) of Low & middle income and Imports(as % of merchandise exports) of Lower middle income?
Provide a short and direct response. 0.48. In the year 1990, what is the difference between the Imports(as % of merchandise exports) in Low & middle income and Imports(as % of merchandise exports) in North America?
Your answer should be compact. 2.54. In the year 1990, what is the difference between the Imports(as % of merchandise exports) in Low & middle income and Imports(as % of merchandise exports) in Papua New Guinea?
Provide a succinct answer. 3.97. In the year 1990, what is the difference between the Imports(as % of merchandise exports) of Lower middle income and Imports(as % of merchandise exports) of North America?
Provide a short and direct response. 2.07. In the year 1990, what is the difference between the Imports(as % of merchandise exports) of Lower middle income and Imports(as % of merchandise exports) of Papua New Guinea?
Provide a succinct answer. 3.49. In the year 1990, what is the difference between the Imports(as % of merchandise exports) in North America and Imports(as % of merchandise exports) in Papua New Guinea?
Your answer should be compact. 1.43. In the year 1998, what is the difference between the Imports(as % of merchandise exports) in Low & middle income and Imports(as % of merchandise exports) in Lower middle income?
Make the answer very short. -0.23. In the year 1998, what is the difference between the Imports(as % of merchandise exports) in Low & middle income and Imports(as % of merchandise exports) in North America?
Make the answer very short. 1.44. In the year 1998, what is the difference between the Imports(as % of merchandise exports) of Low & middle income and Imports(as % of merchandise exports) of Papua New Guinea?
Offer a terse response. 2.36. In the year 1998, what is the difference between the Imports(as % of merchandise exports) of Lower middle income and Imports(as % of merchandise exports) of North America?
Provide a succinct answer. 1.67. In the year 1998, what is the difference between the Imports(as % of merchandise exports) in Lower middle income and Imports(as % of merchandise exports) in Papua New Guinea?
Your response must be concise. 2.59. In the year 1998, what is the difference between the Imports(as % of merchandise exports) in North America and Imports(as % of merchandise exports) in Papua New Guinea?
Your response must be concise. 0.92. What is the ratio of the Imports(as % of merchandise exports) of Low & middle income in 1985 to that in 1986?
Provide a short and direct response. 1.01. What is the ratio of the Imports(as % of merchandise exports) of Lower middle income in 1985 to that in 1986?
Offer a terse response. 0.97. What is the ratio of the Imports(as % of merchandise exports) in North America in 1985 to that in 1986?
Provide a succinct answer. 1.03. What is the ratio of the Imports(as % of merchandise exports) of Papua New Guinea in 1985 to that in 1986?
Make the answer very short. 0.79. What is the ratio of the Imports(as % of merchandise exports) in Low & middle income in 1985 to that in 1987?
Provide a succinct answer. 0.79. What is the ratio of the Imports(as % of merchandise exports) in Lower middle income in 1985 to that in 1987?
Offer a very short reply. 0.88. What is the ratio of the Imports(as % of merchandise exports) of North America in 1985 to that in 1987?
Give a very brief answer. 0.99. What is the ratio of the Imports(as % of merchandise exports) in Papua New Guinea in 1985 to that in 1987?
Offer a very short reply. 0.76. What is the ratio of the Imports(as % of merchandise exports) of Low & middle income in 1985 to that in 1988?
Offer a terse response. 0.7. What is the ratio of the Imports(as % of merchandise exports) of Lower middle income in 1985 to that in 1988?
Your answer should be very brief. 0.78. What is the ratio of the Imports(as % of merchandise exports) in North America in 1985 to that in 1988?
Provide a short and direct response. 0.99. What is the ratio of the Imports(as % of merchandise exports) in Papua New Guinea in 1985 to that in 1988?
Your response must be concise. 0.88. What is the ratio of the Imports(as % of merchandise exports) of Low & middle income in 1985 to that in 1989?
Provide a succinct answer. 0.8. What is the ratio of the Imports(as % of merchandise exports) in Lower middle income in 1985 to that in 1989?
Your answer should be compact. 0.82. What is the ratio of the Imports(as % of merchandise exports) in North America in 1985 to that in 1989?
Give a very brief answer. 0.98. What is the ratio of the Imports(as % of merchandise exports) of Papua New Guinea in 1985 to that in 1989?
Make the answer very short. 1. What is the ratio of the Imports(as % of merchandise exports) in Low & middle income in 1985 to that in 1990?
Your answer should be compact. 0.91. What is the ratio of the Imports(as % of merchandise exports) of Lower middle income in 1985 to that in 1990?
Provide a short and direct response. 0.86. What is the ratio of the Imports(as % of merchandise exports) of North America in 1985 to that in 1990?
Provide a succinct answer. 1.1. What is the ratio of the Imports(as % of merchandise exports) in Papua New Guinea in 1985 to that in 1990?
Keep it short and to the point. 0.83. What is the ratio of the Imports(as % of merchandise exports) in Low & middle income in 1985 to that in 1998?
Ensure brevity in your answer.  1.29. What is the ratio of the Imports(as % of merchandise exports) of Lower middle income in 1985 to that in 1998?
Make the answer very short. 1.01. What is the ratio of the Imports(as % of merchandise exports) of North America in 1985 to that in 1998?
Your answer should be compact. 1.23. What is the ratio of the Imports(as % of merchandise exports) in Papua New Guinea in 1985 to that in 1998?
Ensure brevity in your answer.  0.48. What is the ratio of the Imports(as % of merchandise exports) of Low & middle income in 1986 to that in 1987?
Provide a short and direct response. 0.78. What is the ratio of the Imports(as % of merchandise exports) of Lower middle income in 1986 to that in 1987?
Offer a terse response. 0.9. What is the ratio of the Imports(as % of merchandise exports) in North America in 1986 to that in 1987?
Your answer should be very brief. 0.96. What is the ratio of the Imports(as % of merchandise exports) in Papua New Guinea in 1986 to that in 1987?
Make the answer very short. 0.96. What is the ratio of the Imports(as % of merchandise exports) in Low & middle income in 1986 to that in 1988?
Give a very brief answer. 0.7. What is the ratio of the Imports(as % of merchandise exports) in Lower middle income in 1986 to that in 1988?
Offer a terse response. 0.8. What is the ratio of the Imports(as % of merchandise exports) of North America in 1986 to that in 1988?
Provide a short and direct response. 0.96. What is the ratio of the Imports(as % of merchandise exports) in Papua New Guinea in 1986 to that in 1988?
Keep it short and to the point. 1.11. What is the ratio of the Imports(as % of merchandise exports) of Low & middle income in 1986 to that in 1989?
Provide a short and direct response. 0.79. What is the ratio of the Imports(as % of merchandise exports) in Lower middle income in 1986 to that in 1989?
Your answer should be very brief. 0.85. What is the ratio of the Imports(as % of merchandise exports) of North America in 1986 to that in 1989?
Ensure brevity in your answer.  0.95. What is the ratio of the Imports(as % of merchandise exports) in Papua New Guinea in 1986 to that in 1989?
Your response must be concise. 1.26. What is the ratio of the Imports(as % of merchandise exports) in Low & middle income in 1986 to that in 1990?
Keep it short and to the point. 0.9. What is the ratio of the Imports(as % of merchandise exports) of Lower middle income in 1986 to that in 1990?
Your answer should be very brief. 0.89. What is the ratio of the Imports(as % of merchandise exports) of North America in 1986 to that in 1990?
Your answer should be compact. 1.07. What is the ratio of the Imports(as % of merchandise exports) of Papua New Guinea in 1986 to that in 1990?
Give a very brief answer. 1.06. What is the ratio of the Imports(as % of merchandise exports) in Low & middle income in 1986 to that in 1998?
Make the answer very short. 1.27. What is the ratio of the Imports(as % of merchandise exports) of Lower middle income in 1986 to that in 1998?
Your response must be concise. 1.04. What is the ratio of the Imports(as % of merchandise exports) of North America in 1986 to that in 1998?
Keep it short and to the point. 1.19. What is the ratio of the Imports(as % of merchandise exports) of Papua New Guinea in 1986 to that in 1998?
Ensure brevity in your answer.  0.61. What is the ratio of the Imports(as % of merchandise exports) of Low & middle income in 1987 to that in 1988?
Your answer should be compact. 0.89. What is the ratio of the Imports(as % of merchandise exports) of Lower middle income in 1987 to that in 1988?
Your answer should be compact. 0.89. What is the ratio of the Imports(as % of merchandise exports) of North America in 1987 to that in 1988?
Your answer should be very brief. 1. What is the ratio of the Imports(as % of merchandise exports) in Papua New Guinea in 1987 to that in 1988?
Offer a terse response. 1.16. What is the ratio of the Imports(as % of merchandise exports) in Low & middle income in 1987 to that in 1989?
Offer a terse response. 1.01. What is the ratio of the Imports(as % of merchandise exports) in Lower middle income in 1987 to that in 1989?
Provide a short and direct response. 0.94. What is the ratio of the Imports(as % of merchandise exports) of North America in 1987 to that in 1989?
Ensure brevity in your answer.  0.99. What is the ratio of the Imports(as % of merchandise exports) of Papua New Guinea in 1987 to that in 1989?
Give a very brief answer. 1.32. What is the ratio of the Imports(as % of merchandise exports) of Low & middle income in 1987 to that in 1990?
Offer a terse response. 1.15. What is the ratio of the Imports(as % of merchandise exports) in Lower middle income in 1987 to that in 1990?
Provide a succinct answer. 0.98. What is the ratio of the Imports(as % of merchandise exports) in North America in 1987 to that in 1990?
Your answer should be very brief. 1.12. What is the ratio of the Imports(as % of merchandise exports) of Papua New Guinea in 1987 to that in 1990?
Your answer should be compact. 1.1. What is the ratio of the Imports(as % of merchandise exports) of Low & middle income in 1987 to that in 1998?
Offer a very short reply. 1.63. What is the ratio of the Imports(as % of merchandise exports) in Lower middle income in 1987 to that in 1998?
Provide a succinct answer. 1.15. What is the ratio of the Imports(as % of merchandise exports) of North America in 1987 to that in 1998?
Your answer should be very brief. 1.24. What is the ratio of the Imports(as % of merchandise exports) of Papua New Guinea in 1987 to that in 1998?
Keep it short and to the point. 0.63. What is the ratio of the Imports(as % of merchandise exports) in Low & middle income in 1988 to that in 1989?
Ensure brevity in your answer.  1.13. What is the ratio of the Imports(as % of merchandise exports) of Lower middle income in 1988 to that in 1989?
Offer a very short reply. 1.06. What is the ratio of the Imports(as % of merchandise exports) in North America in 1988 to that in 1989?
Offer a terse response. 0.99. What is the ratio of the Imports(as % of merchandise exports) in Papua New Guinea in 1988 to that in 1989?
Your answer should be very brief. 1.14. What is the ratio of the Imports(as % of merchandise exports) of Low & middle income in 1988 to that in 1990?
Make the answer very short. 1.29. What is the ratio of the Imports(as % of merchandise exports) in Lower middle income in 1988 to that in 1990?
Give a very brief answer. 1.11. What is the ratio of the Imports(as % of merchandise exports) in North America in 1988 to that in 1990?
Provide a short and direct response. 1.12. What is the ratio of the Imports(as % of merchandise exports) in Papua New Guinea in 1988 to that in 1990?
Keep it short and to the point. 0.95. What is the ratio of the Imports(as % of merchandise exports) in Low & middle income in 1988 to that in 1998?
Your answer should be very brief. 1.82. What is the ratio of the Imports(as % of merchandise exports) of Lower middle income in 1988 to that in 1998?
Offer a terse response. 1.3. What is the ratio of the Imports(as % of merchandise exports) of North America in 1988 to that in 1998?
Offer a very short reply. 1.24. What is the ratio of the Imports(as % of merchandise exports) in Papua New Guinea in 1988 to that in 1998?
Your answer should be compact. 0.54. What is the ratio of the Imports(as % of merchandise exports) of Low & middle income in 1989 to that in 1990?
Offer a very short reply. 1.14. What is the ratio of the Imports(as % of merchandise exports) of Lower middle income in 1989 to that in 1990?
Keep it short and to the point. 1.05. What is the ratio of the Imports(as % of merchandise exports) in North America in 1989 to that in 1990?
Offer a terse response. 1.13. What is the ratio of the Imports(as % of merchandise exports) of Papua New Guinea in 1989 to that in 1990?
Give a very brief answer. 0.84. What is the ratio of the Imports(as % of merchandise exports) in Low & middle income in 1989 to that in 1998?
Make the answer very short. 1.62. What is the ratio of the Imports(as % of merchandise exports) in Lower middle income in 1989 to that in 1998?
Keep it short and to the point. 1.23. What is the ratio of the Imports(as % of merchandise exports) in North America in 1989 to that in 1998?
Your answer should be very brief. 1.26. What is the ratio of the Imports(as % of merchandise exports) in Papua New Guinea in 1989 to that in 1998?
Ensure brevity in your answer.  0.48. What is the ratio of the Imports(as % of merchandise exports) of Low & middle income in 1990 to that in 1998?
Provide a succinct answer. 1.41. What is the ratio of the Imports(as % of merchandise exports) in Lower middle income in 1990 to that in 1998?
Provide a succinct answer. 1.17. What is the ratio of the Imports(as % of merchandise exports) in North America in 1990 to that in 1998?
Keep it short and to the point. 1.11. What is the ratio of the Imports(as % of merchandise exports) in Papua New Guinea in 1990 to that in 1998?
Provide a succinct answer. 0.57. What is the difference between the highest and the second highest Imports(as % of merchandise exports) of Low & middle income?
Ensure brevity in your answer.  0.61. What is the difference between the highest and the second highest Imports(as % of merchandise exports) of Lower middle income?
Provide a succinct answer. 0.25. What is the difference between the highest and the second highest Imports(as % of merchandise exports) in North America?
Your response must be concise. 0.02. What is the difference between the highest and the second highest Imports(as % of merchandise exports) of Papua New Guinea?
Your answer should be compact. 0.28. What is the difference between the highest and the lowest Imports(as % of merchandise exports) of Low & middle income?
Provide a short and direct response. 2.57. What is the difference between the highest and the lowest Imports(as % of merchandise exports) of Lower middle income?
Make the answer very short. 1.01. What is the difference between the highest and the lowest Imports(as % of merchandise exports) in North America?
Your answer should be compact. 0.43. What is the difference between the highest and the lowest Imports(as % of merchandise exports) in Papua New Guinea?
Offer a terse response. 0.4. 